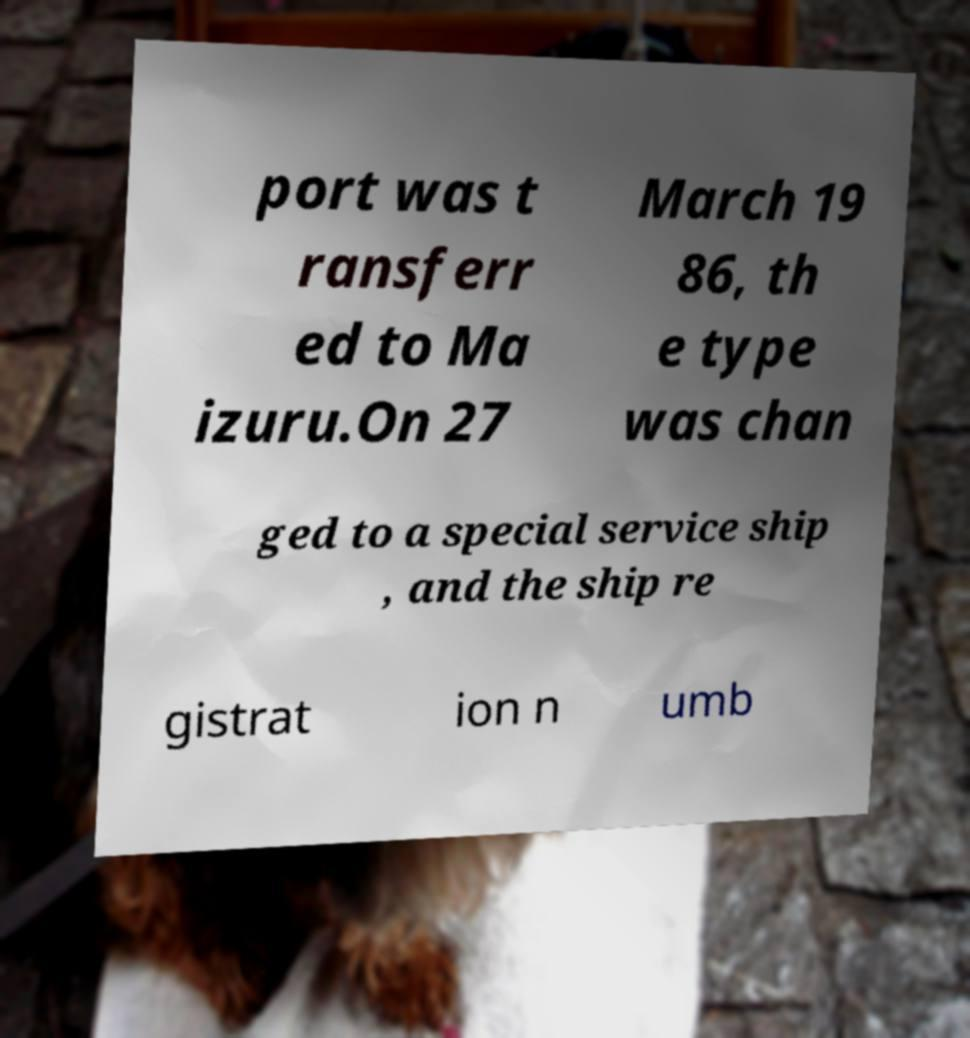For documentation purposes, I need the text within this image transcribed. Could you provide that? port was t ransferr ed to Ma izuru.On 27 March 19 86, th e type was chan ged to a special service ship , and the ship re gistrat ion n umb 